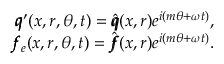<formula> <loc_0><loc_0><loc_500><loc_500>\begin{array} { r } { \pm b q ^ { \prime } ( x , r , \theta , t ) = \hat { \pm b q } ( x , r ) e ^ { i ( m \theta + \omega t ) } , } \\ { \pm b f _ { e } ( x , r , \theta , t ) = \hat { \pm b f } ( x , r ) e ^ { i ( m \theta + \omega t ) } . } \end{array}</formula> 